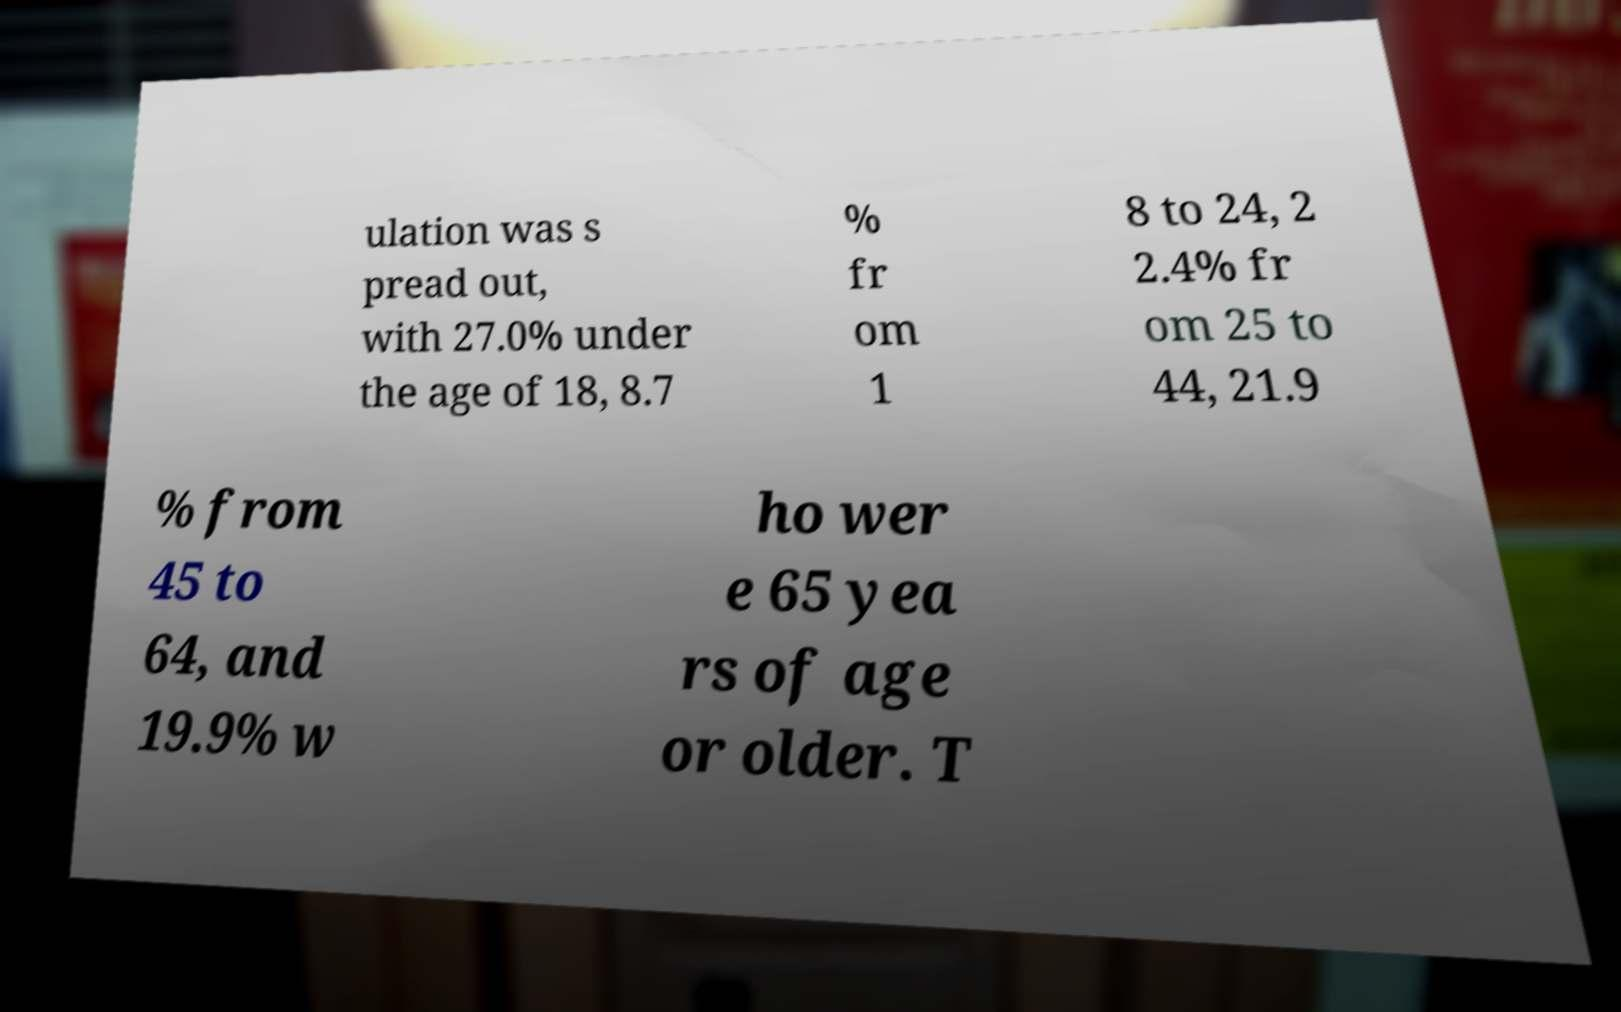Please identify and transcribe the text found in this image. ulation was s pread out, with 27.0% under the age of 18, 8.7 % fr om 1 8 to 24, 2 2.4% fr om 25 to 44, 21.9 % from 45 to 64, and 19.9% w ho wer e 65 yea rs of age or older. T 